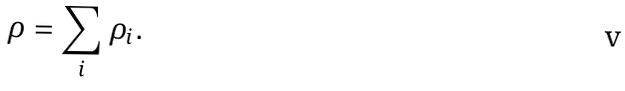<formula> <loc_0><loc_0><loc_500><loc_500>\rho = \sum _ { i } \rho _ { i } .</formula> 